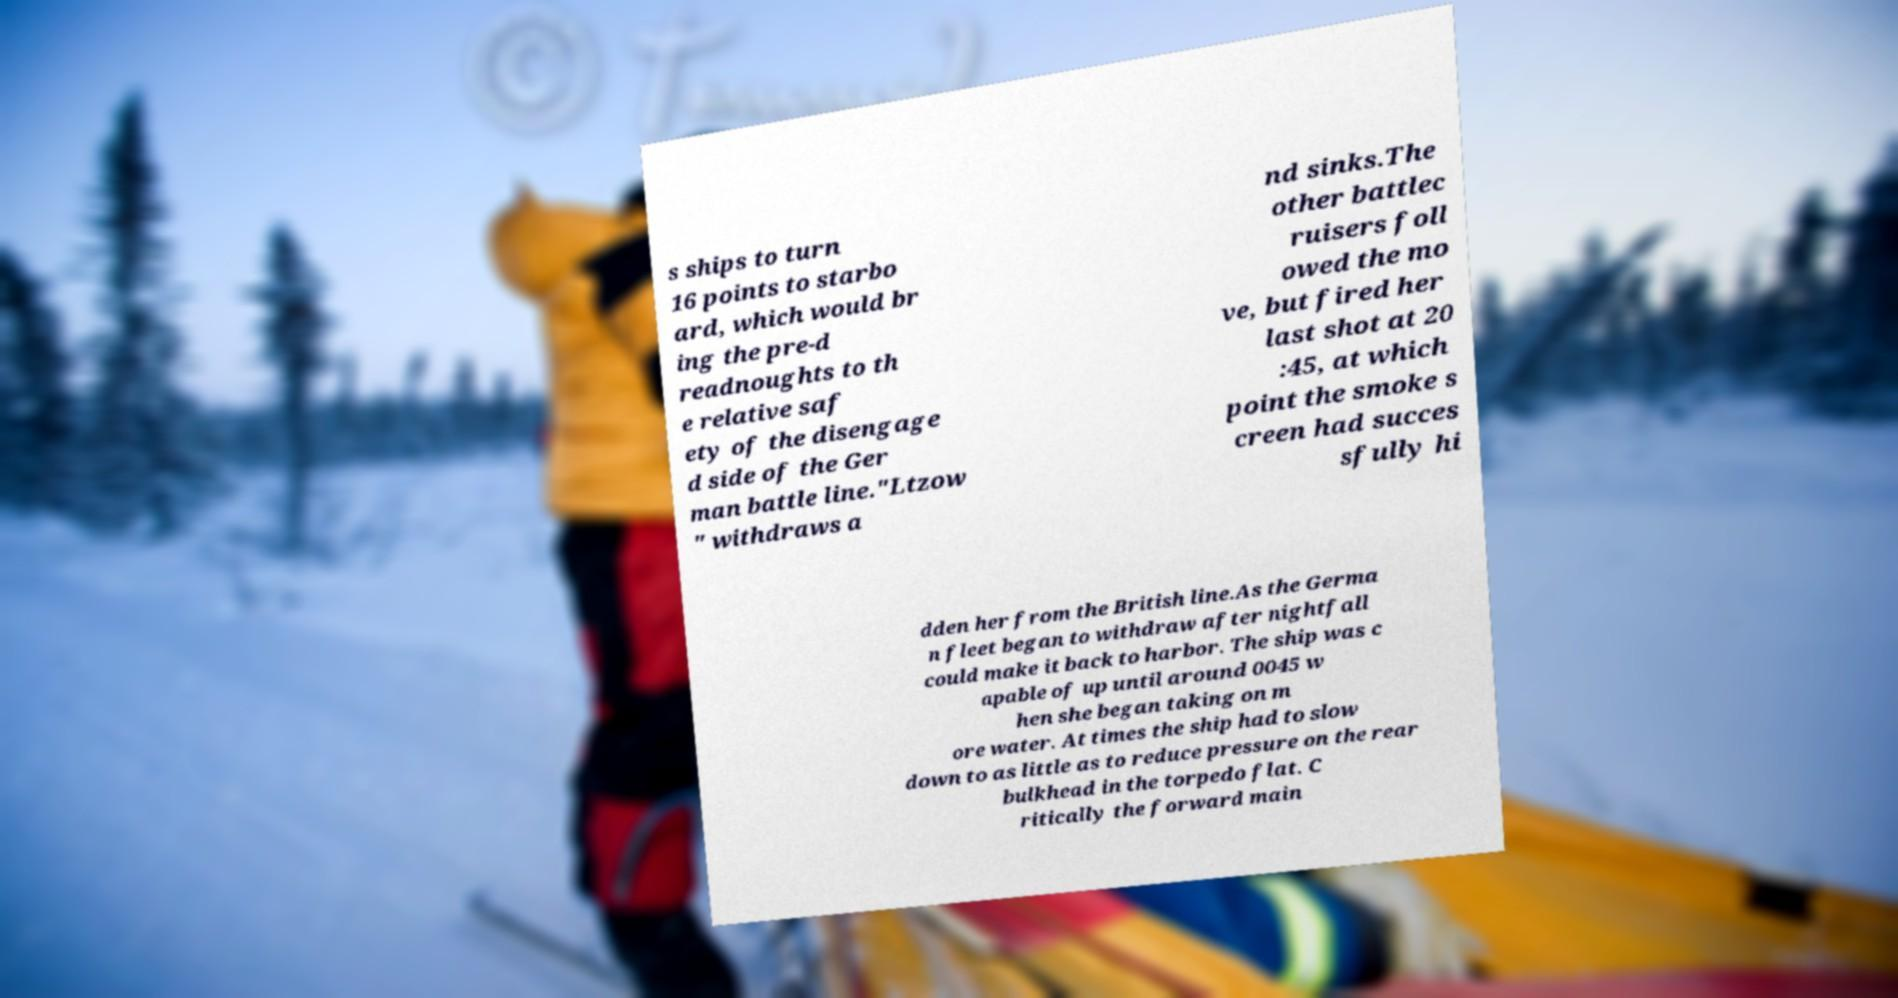Please read and relay the text visible in this image. What does it say? s ships to turn 16 points to starbo ard, which would br ing the pre-d readnoughts to th e relative saf ety of the disengage d side of the Ger man battle line."Ltzow " withdraws a nd sinks.The other battlec ruisers foll owed the mo ve, but fired her last shot at 20 :45, at which point the smoke s creen had succes sfully hi dden her from the British line.As the Germa n fleet began to withdraw after nightfall could make it back to harbor. The ship was c apable of up until around 0045 w hen she began taking on m ore water. At times the ship had to slow down to as little as to reduce pressure on the rear bulkhead in the torpedo flat. C ritically the forward main 